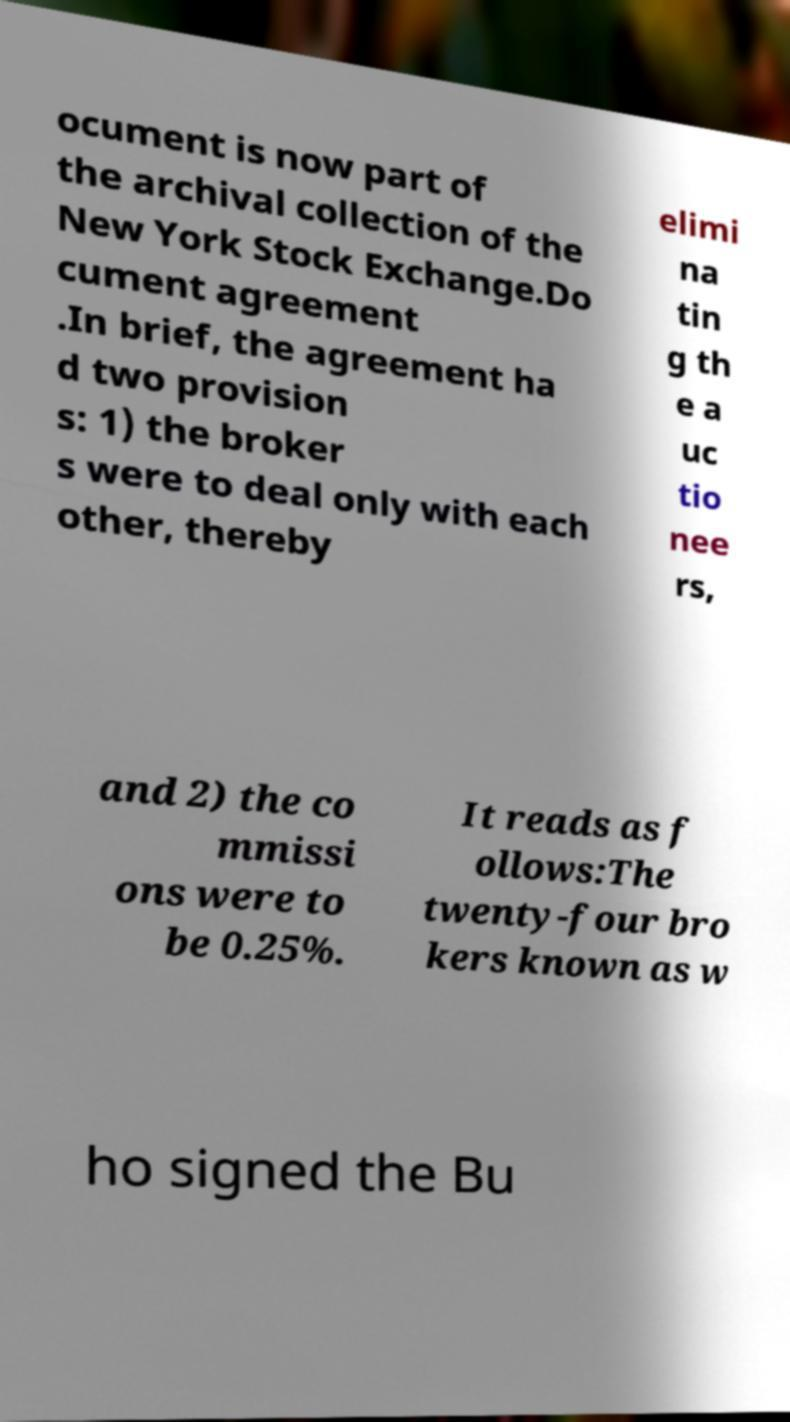I need the written content from this picture converted into text. Can you do that? ocument is now part of the archival collection of the New York Stock Exchange.Do cument agreement .In brief, the agreement ha d two provision s: 1) the broker s were to deal only with each other, thereby elimi na tin g th e a uc tio nee rs, and 2) the co mmissi ons were to be 0.25%. It reads as f ollows:The twenty-four bro kers known as w ho signed the Bu 